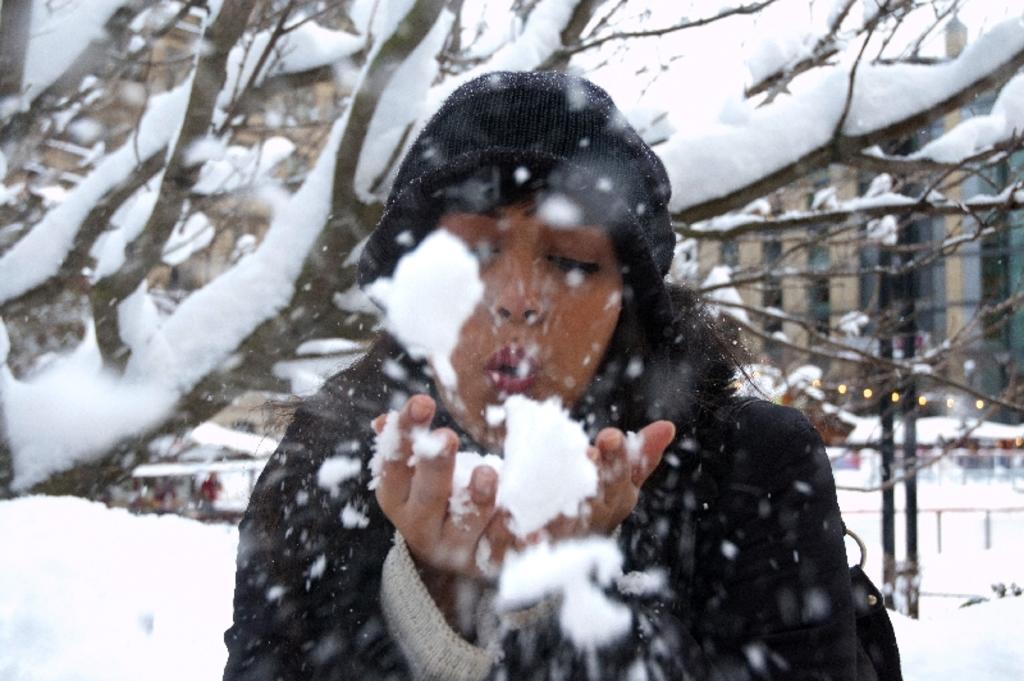Could you give a brief overview of what you see in this image? There is a woman wearing a cap is having snow on the hands. In the back there are trees, buildings, lights and poles. And it is covered with snow. 